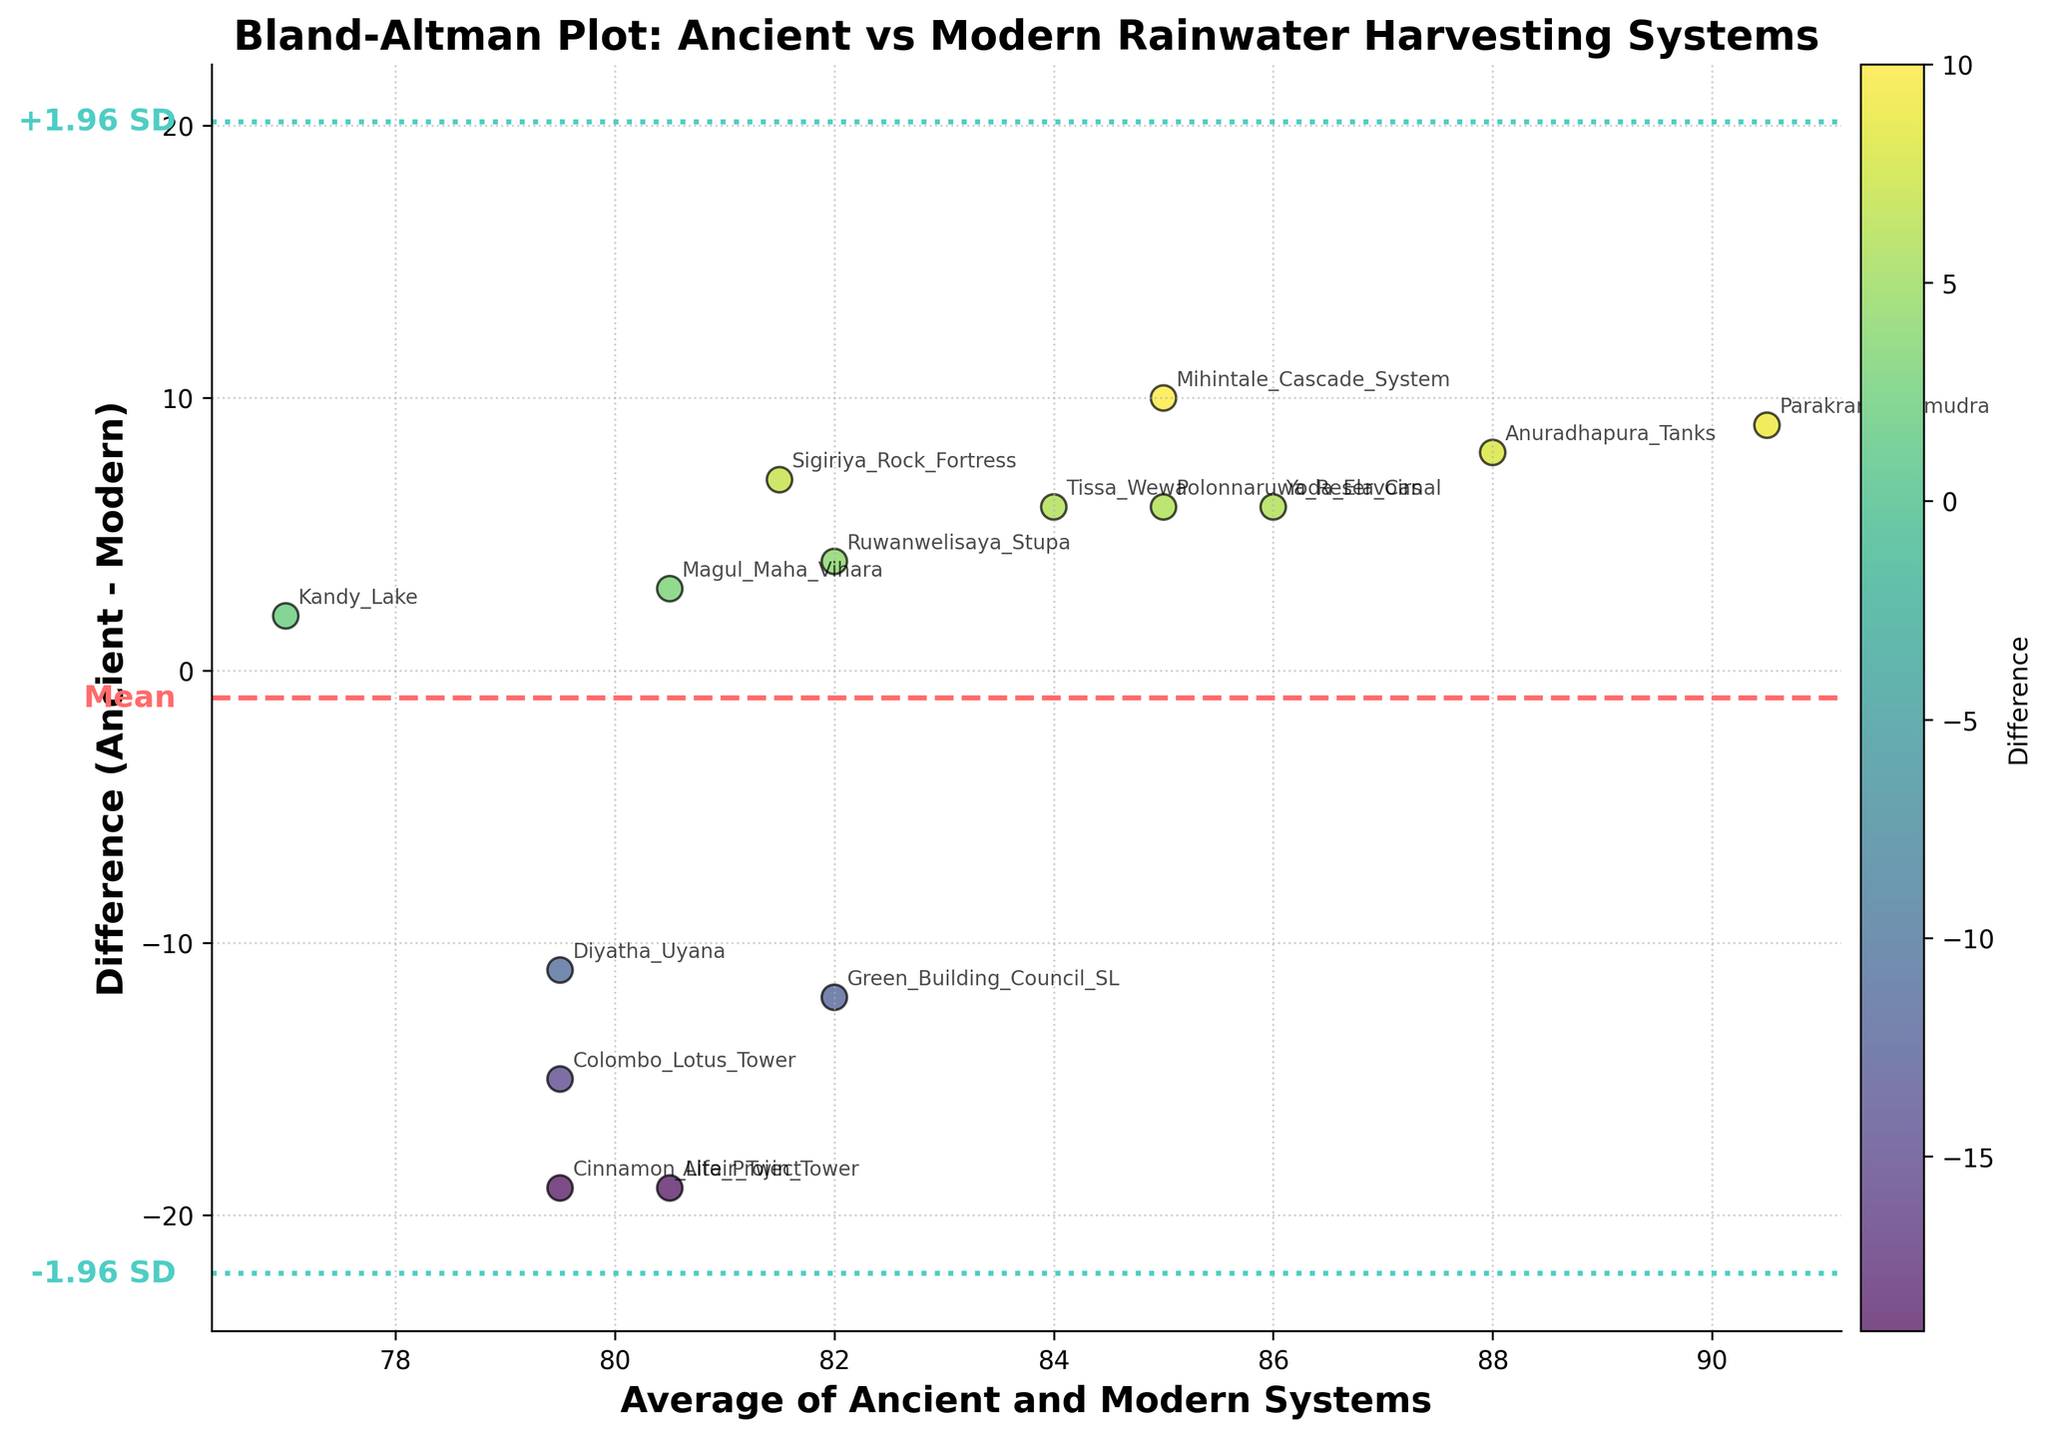What is the title of the plot? The title of the plot is prominently displayed at the top and often summarizes the plot’s purpose in a few words. Here, it reads: "Bland-Altman Plot: Ancient vs Modern Rainwater Harvesting Systems"
Answer: Bland-Altman Plot: Ancient vs Modern Rainwater Harvesting Systems What are the colors of the lines representing the mean and the boundaries of the 95% limits? The lines' colors help differentiate the mean and the statistical boundaries quickly. The mean is represented by a dashed red line, and the 95% limits are shown with dotted teal lines.
Answer: Red for mean, Teal for 95% limits How many data points are plotted in the figure? Each data point represents a single rainwater harvesting system's efficiency comparison between ancient and modern practices. By counting the annotated labels or the markers, there are 15 data points.
Answer: 15 What does the X-axis represent and what are its units? The X-axis label is crucial for understanding the type of data measured. It is "Average of Ancient and Modern Systems," which indicates the mean value of efficiency between the two systems, without specifying particular units.
Answer: Average of Ancient and Modern Systems Which site showed the greatest positive difference in efficiency between the ancient and modern systems? Looking at the Y-axis values, the highest positive difference (most above zero) represents the site where the ancient system performed significantly better than modern practices. This is the "Mihintale Cascade System" with a difference of 10.
Answer: Mihintale Cascade System Which site had the lowest efficiency difference, indicating nearly comparable performance between ancient and modern systems? Identify the point closest to zero on the Y-axis, which indicates minimal discrepancy between the two systems. "Kandy Lake" has a difference of 2, the smallest positive value.
Answer: Kandy Lake Where do the majority of ancient systems perform better or worse than modern practices, based on their position above or below the mean line? Observing the number of data points above and below the mean line (red dashed line) can indicate whether ancient systems generally outperform modern practices or vice versa. The data points above the mean line indicate ancient systems performing better.
Answer: Majority perform better Which modern building project had the highest discrepancy when compared with an ancient system, and what was the difference? By looking for the lowest Y-axis values (below zero), the modern project with the most negative difference is easily spotted. The "Cinnamon Life Project" and "Altair Twin Tower" both have a large negative difference of -19.
Answer: Cinnamon Life Project and Altair Twin Tower, -19 What does a point below the mean line indicate about the rainwater harvesting efficiency comparison for that particular site? A point below the mean line indicates that the modern practice is more efficient than the ancient system at that particular site.
Answer: Modern practice is more efficient How do the majority of modern practices compare in efficiency to ancient systems, given the placement of points on the plot? By counting and contrasting the number of points below and above the mean line, the prevalent trend can be seen. Majority of points are above the mean line indicating that modern practices are generally less efficient than ancient systems.
Answer: Modern practices are generally less efficient 